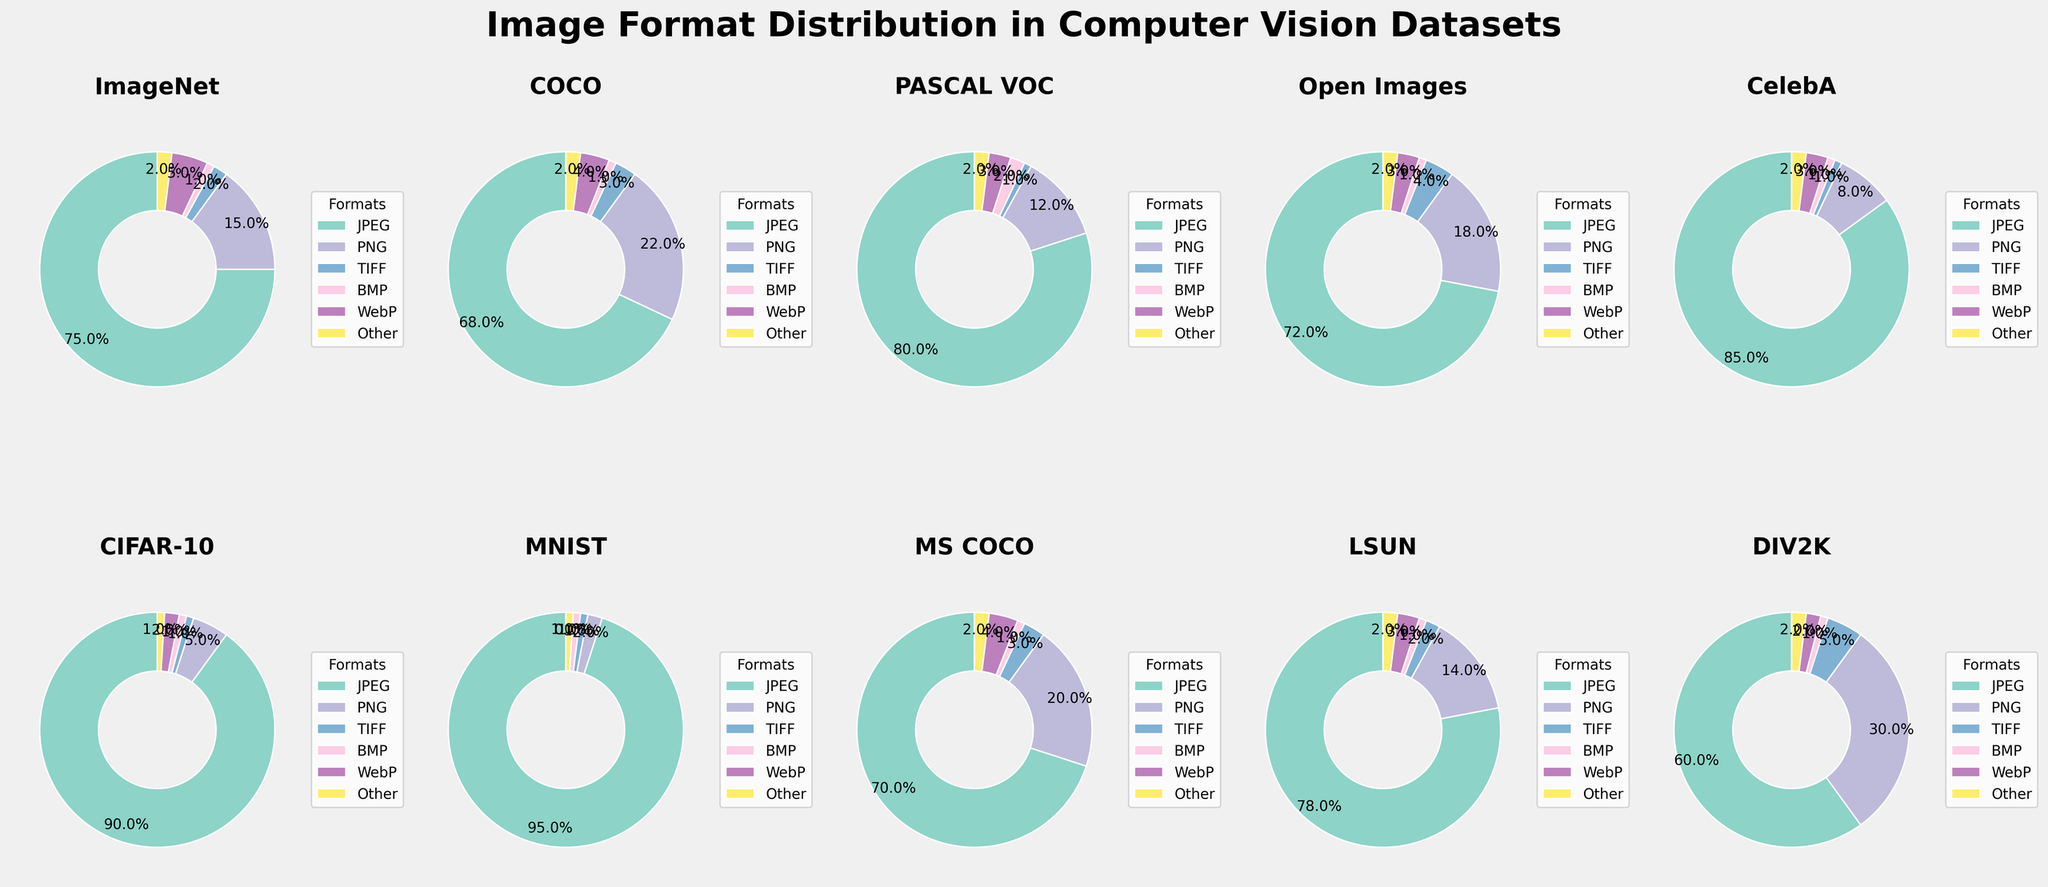Which dataset has the highest usage of JPEG format? Looking at the pie charts, CIFAR-10 shows the highest usage of JPEG format with 90%.
Answer: CIFAR-10 Which dataset has the smallest usage of PNG format? From the pie charts, MNIST has the smallest usage of PNG format at 2%.
Answer: MNIST Compare JPEG usage between ImageNet and COCO datasets. Which one has a higher percentage? By comparing the pie charts, ImageNet has 75% JPEG, while COCO has 68% JPEG. Thus, ImageNet has a higher percentage.
Answer: ImageNet What's the sum of PNG and WebP usage in the DIV2K dataset? DIV2K has 30% for PNG and 2% for WebP. Summing these percentages, we get 30 + 2 = 32%.
Answer: 32% Which dataset shows a similar distribution of JPEG and PNG usages? By examining the pie charts closely, the Open Images dataset has a closer balance with 72% JPEG and 18% PNG. Others have a larger disparity between JPEG and PNG.
Answer: Open Images Which dataset has the highest number of formats each having a share of at least 5%? Inspecting the pie charts, DIV2K shows multiple formats (JPEG, PNG, TIFF) each having at least 5%, totaling 3 formats.
Answer: DIV2K Which dataset has more BMP format usage, PASCAL VOC or Open Images? The pie chart indicates that PASCAL VOC has 2% BMP usage, whereas Open Images has only 1% BMP. Thus, PASCAL VOC has more BMP.
Answer: PASCAL VOC Calculate the average TIFF usage across all datasets. Summing the TIFF usage: 2 + 3 + 1 + 4 + 1 + 1 + 1 + 3 + 2 + 5 = 23. There are 10 datasets, so the average is 23/10 = 2.3%.
Answer: 2.3% What is the total percentage of ‘Other’ format across all datasets? Summing the 'Other' format usage in all datasets: 2 + 2 + 2 + 2 + 2 + 1 + 1 + 2 + 2 + 2 = 18%.
Answer: 18% Which dataset has the second-highest PNG usage? From the pie charts, DIV2K has the highest PNG usage at 30%, making COCO, with 22%, the second highest.
Answer: COCO 